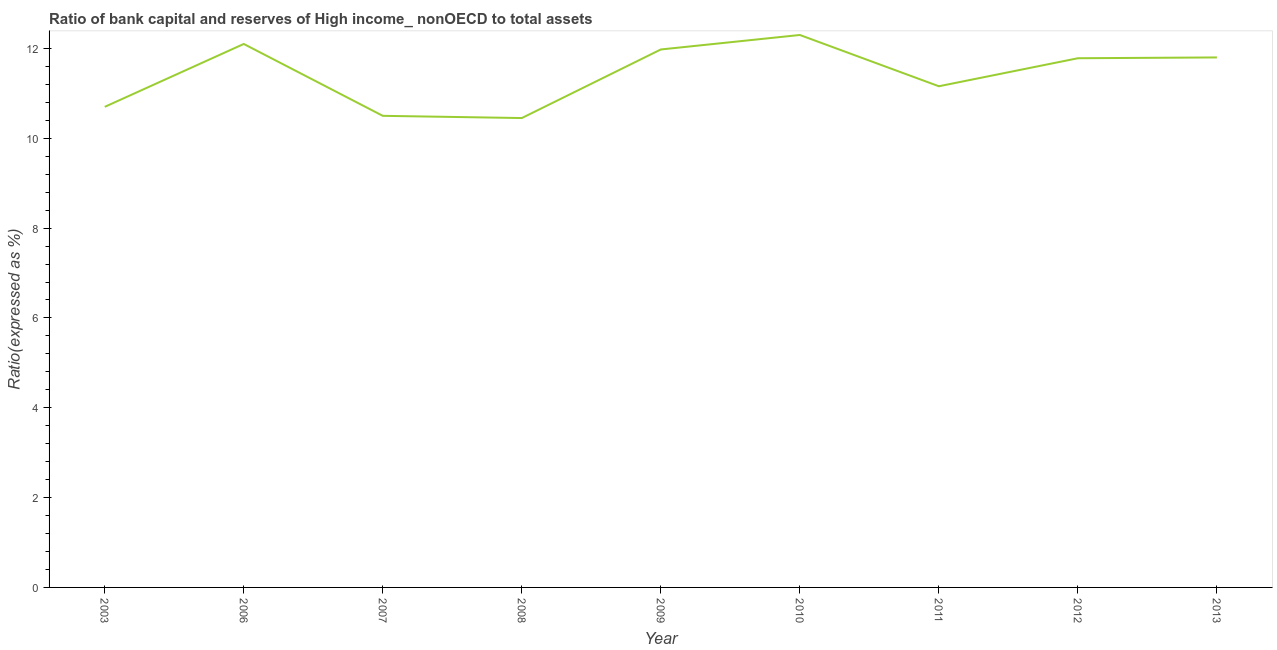What is the bank capital to assets ratio in 2008?
Keep it short and to the point. 10.45. Across all years, what is the minimum bank capital to assets ratio?
Give a very brief answer. 10.45. In which year was the bank capital to assets ratio maximum?
Provide a succinct answer. 2010. In which year was the bank capital to assets ratio minimum?
Make the answer very short. 2008. What is the sum of the bank capital to assets ratio?
Your response must be concise. 102.77. What is the difference between the bank capital to assets ratio in 2012 and 2013?
Provide a succinct answer. -0.02. What is the average bank capital to assets ratio per year?
Provide a short and direct response. 11.42. What is the median bank capital to assets ratio?
Make the answer very short. 11.78. Do a majority of the years between 2009 and 2006 (inclusive) have bank capital to assets ratio greater than 9.2 %?
Offer a very short reply. Yes. What is the ratio of the bank capital to assets ratio in 2006 to that in 2010?
Offer a terse response. 0.98. Is the bank capital to assets ratio in 2003 less than that in 2012?
Offer a very short reply. Yes. Is the difference between the bank capital to assets ratio in 2003 and 2012 greater than the difference between any two years?
Offer a terse response. No. What is the difference between the highest and the second highest bank capital to assets ratio?
Provide a succinct answer. 0.2. Is the sum of the bank capital to assets ratio in 2003 and 2008 greater than the maximum bank capital to assets ratio across all years?
Ensure brevity in your answer.  Yes. What is the difference between the highest and the lowest bank capital to assets ratio?
Offer a very short reply. 1.85. Does the bank capital to assets ratio monotonically increase over the years?
Your answer should be very brief. No. How many years are there in the graph?
Provide a short and direct response. 9. Does the graph contain any zero values?
Offer a very short reply. No. Does the graph contain grids?
Ensure brevity in your answer.  No. What is the title of the graph?
Ensure brevity in your answer.  Ratio of bank capital and reserves of High income_ nonOECD to total assets. What is the label or title of the Y-axis?
Keep it short and to the point. Ratio(expressed as %). What is the Ratio(expressed as %) in 2006?
Ensure brevity in your answer.  12.1. What is the Ratio(expressed as %) in 2008?
Offer a terse response. 10.45. What is the Ratio(expressed as %) in 2009?
Your response must be concise. 11.98. What is the Ratio(expressed as %) of 2011?
Offer a very short reply. 11.16. What is the Ratio(expressed as %) in 2012?
Your answer should be compact. 11.78. What is the difference between the Ratio(expressed as %) in 2003 and 2007?
Provide a short and direct response. 0.2. What is the difference between the Ratio(expressed as %) in 2003 and 2008?
Your answer should be very brief. 0.25. What is the difference between the Ratio(expressed as %) in 2003 and 2009?
Offer a terse response. -1.28. What is the difference between the Ratio(expressed as %) in 2003 and 2011?
Keep it short and to the point. -0.46. What is the difference between the Ratio(expressed as %) in 2003 and 2012?
Make the answer very short. -1.08. What is the difference between the Ratio(expressed as %) in 2006 and 2008?
Give a very brief answer. 1.65. What is the difference between the Ratio(expressed as %) in 2006 and 2009?
Make the answer very short. 0.12. What is the difference between the Ratio(expressed as %) in 2006 and 2010?
Offer a terse response. -0.2. What is the difference between the Ratio(expressed as %) in 2006 and 2011?
Make the answer very short. 0.94. What is the difference between the Ratio(expressed as %) in 2006 and 2012?
Offer a terse response. 0.32. What is the difference between the Ratio(expressed as %) in 2007 and 2008?
Make the answer very short. 0.05. What is the difference between the Ratio(expressed as %) in 2007 and 2009?
Offer a very short reply. -1.48. What is the difference between the Ratio(expressed as %) in 2007 and 2010?
Your response must be concise. -1.8. What is the difference between the Ratio(expressed as %) in 2007 and 2011?
Offer a very short reply. -0.66. What is the difference between the Ratio(expressed as %) in 2007 and 2012?
Make the answer very short. -1.28. What is the difference between the Ratio(expressed as %) in 2007 and 2013?
Offer a very short reply. -1.3. What is the difference between the Ratio(expressed as %) in 2008 and 2009?
Give a very brief answer. -1.53. What is the difference between the Ratio(expressed as %) in 2008 and 2010?
Make the answer very short. -1.85. What is the difference between the Ratio(expressed as %) in 2008 and 2011?
Your answer should be very brief. -0.71. What is the difference between the Ratio(expressed as %) in 2008 and 2012?
Provide a succinct answer. -1.33. What is the difference between the Ratio(expressed as %) in 2008 and 2013?
Your answer should be very brief. -1.35. What is the difference between the Ratio(expressed as %) in 2009 and 2010?
Provide a short and direct response. -0.32. What is the difference between the Ratio(expressed as %) in 2009 and 2011?
Provide a succinct answer. 0.82. What is the difference between the Ratio(expressed as %) in 2009 and 2012?
Your answer should be compact. 0.2. What is the difference between the Ratio(expressed as %) in 2009 and 2013?
Your answer should be very brief. 0.18. What is the difference between the Ratio(expressed as %) in 2010 and 2011?
Keep it short and to the point. 1.14. What is the difference between the Ratio(expressed as %) in 2010 and 2012?
Ensure brevity in your answer.  0.52. What is the difference between the Ratio(expressed as %) in 2011 and 2012?
Keep it short and to the point. -0.62. What is the difference between the Ratio(expressed as %) in 2011 and 2013?
Your answer should be very brief. -0.64. What is the difference between the Ratio(expressed as %) in 2012 and 2013?
Your response must be concise. -0.02. What is the ratio of the Ratio(expressed as %) in 2003 to that in 2006?
Offer a very short reply. 0.88. What is the ratio of the Ratio(expressed as %) in 2003 to that in 2007?
Ensure brevity in your answer.  1.02. What is the ratio of the Ratio(expressed as %) in 2003 to that in 2008?
Your answer should be compact. 1.02. What is the ratio of the Ratio(expressed as %) in 2003 to that in 2009?
Your answer should be very brief. 0.89. What is the ratio of the Ratio(expressed as %) in 2003 to that in 2010?
Offer a terse response. 0.87. What is the ratio of the Ratio(expressed as %) in 2003 to that in 2012?
Your answer should be very brief. 0.91. What is the ratio of the Ratio(expressed as %) in 2003 to that in 2013?
Ensure brevity in your answer.  0.91. What is the ratio of the Ratio(expressed as %) in 2006 to that in 2007?
Offer a very short reply. 1.15. What is the ratio of the Ratio(expressed as %) in 2006 to that in 2008?
Provide a succinct answer. 1.16. What is the ratio of the Ratio(expressed as %) in 2006 to that in 2009?
Provide a succinct answer. 1.01. What is the ratio of the Ratio(expressed as %) in 2006 to that in 2011?
Your response must be concise. 1.08. What is the ratio of the Ratio(expressed as %) in 2006 to that in 2012?
Give a very brief answer. 1.03. What is the ratio of the Ratio(expressed as %) in 2007 to that in 2008?
Your answer should be very brief. 1. What is the ratio of the Ratio(expressed as %) in 2007 to that in 2009?
Your answer should be very brief. 0.88. What is the ratio of the Ratio(expressed as %) in 2007 to that in 2010?
Give a very brief answer. 0.85. What is the ratio of the Ratio(expressed as %) in 2007 to that in 2011?
Your answer should be very brief. 0.94. What is the ratio of the Ratio(expressed as %) in 2007 to that in 2012?
Keep it short and to the point. 0.89. What is the ratio of the Ratio(expressed as %) in 2007 to that in 2013?
Make the answer very short. 0.89. What is the ratio of the Ratio(expressed as %) in 2008 to that in 2009?
Offer a very short reply. 0.87. What is the ratio of the Ratio(expressed as %) in 2008 to that in 2011?
Keep it short and to the point. 0.94. What is the ratio of the Ratio(expressed as %) in 2008 to that in 2012?
Give a very brief answer. 0.89. What is the ratio of the Ratio(expressed as %) in 2008 to that in 2013?
Give a very brief answer. 0.89. What is the ratio of the Ratio(expressed as %) in 2009 to that in 2010?
Ensure brevity in your answer.  0.97. What is the ratio of the Ratio(expressed as %) in 2009 to that in 2011?
Your answer should be very brief. 1.07. What is the ratio of the Ratio(expressed as %) in 2009 to that in 2012?
Provide a short and direct response. 1.02. What is the ratio of the Ratio(expressed as %) in 2010 to that in 2011?
Your answer should be very brief. 1.1. What is the ratio of the Ratio(expressed as %) in 2010 to that in 2012?
Offer a terse response. 1.04. What is the ratio of the Ratio(expressed as %) in 2010 to that in 2013?
Provide a succinct answer. 1.04. What is the ratio of the Ratio(expressed as %) in 2011 to that in 2012?
Keep it short and to the point. 0.95. What is the ratio of the Ratio(expressed as %) in 2011 to that in 2013?
Provide a short and direct response. 0.95. What is the ratio of the Ratio(expressed as %) in 2012 to that in 2013?
Provide a succinct answer. 1. 